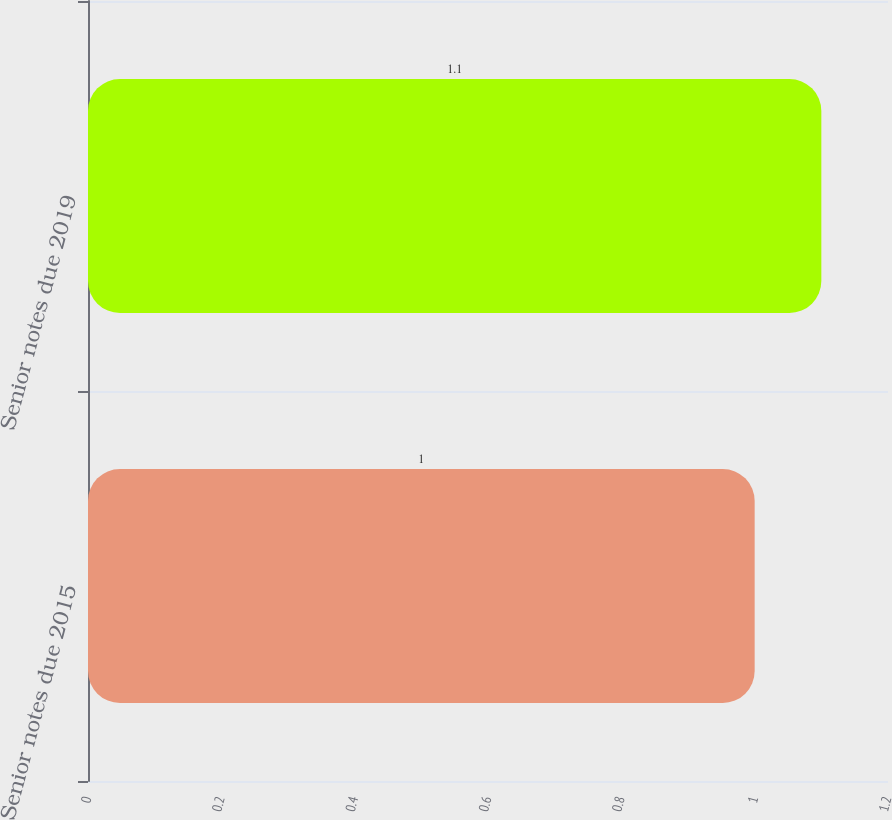Convert chart to OTSL. <chart><loc_0><loc_0><loc_500><loc_500><bar_chart><fcel>Senior notes due 2015<fcel>Senior notes due 2019<nl><fcel>1<fcel>1.1<nl></chart> 